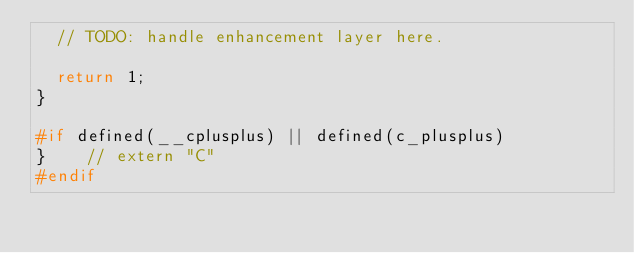<code> <loc_0><loc_0><loc_500><loc_500><_C_>  // TODO: handle enhancement layer here.

  return 1;
}

#if defined(__cplusplus) || defined(c_plusplus)
}    // extern "C"
#endif
</code> 